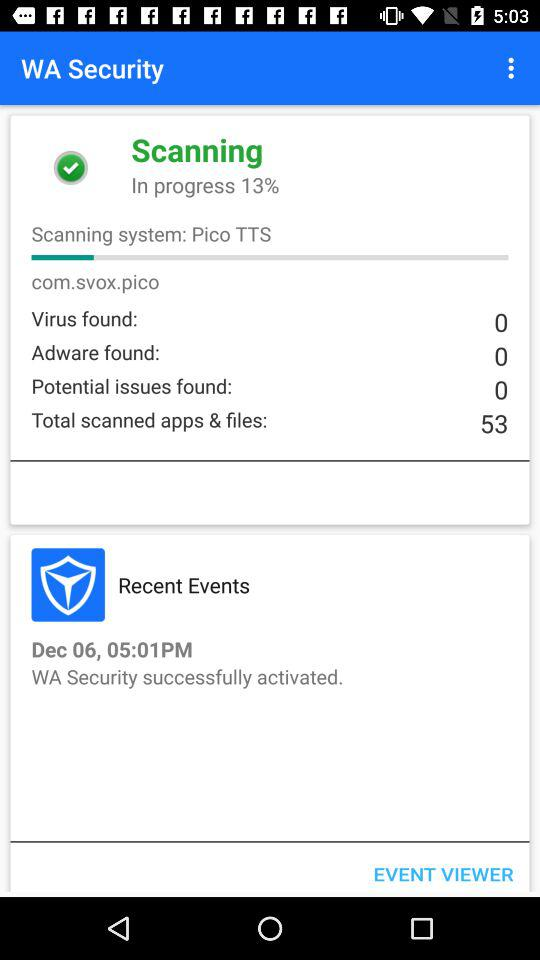What is the date of the recent events? The date of the recent events is 6th December. 